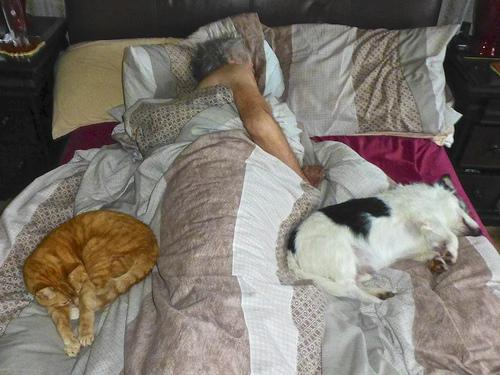Question: what animal is on the left?
Choices:
A. Dog.
B. Cat.
C. Zebra.
D. Elephant.
Answer with the letter. Answer: B Question: what animals is on the right?
Choices:
A. Dog.
B. Cat.
C. Hippo.
D. Penguin.
Answer with the letter. Answer: A Question: where are they all lying?
Choices:
A. Bed.
B. Floor.
C. Mat.
D. Sofa.
Answer with the letter. Answer: A Question: what color are the sheets?
Choices:
A. White.
B. Red.
C. Yellow.
D. Blue.
Answer with the letter. Answer: B Question: how many pillows are there?
Choices:
A. Six.
B. Four.
C. Two.
D. Three.
Answer with the letter. Answer: D Question: why are they lying there?
Choices:
A. Hiding.
B. Sleeping.
C. They are sick.
D. Playing.
Answer with the letter. Answer: B 